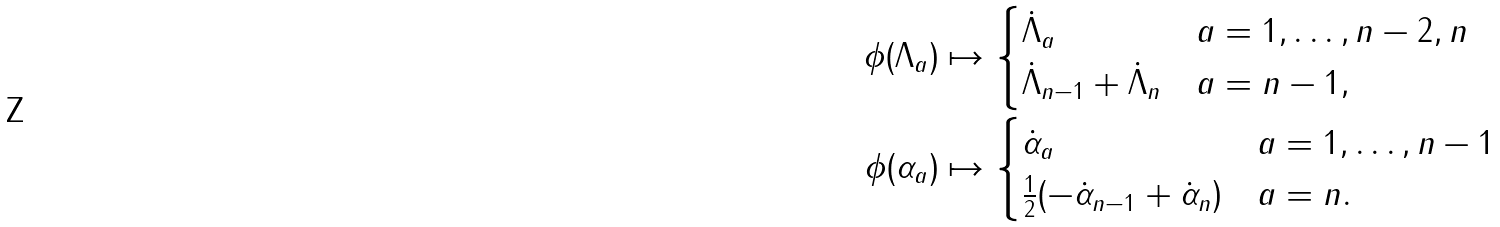<formula> <loc_0><loc_0><loc_500><loc_500>\phi ( \Lambda _ { a } ) & \mapsto \begin{cases} \dot { \Lambda } _ { a } & a = 1 , \dots , n - 2 , n \\ \dot { \Lambda } _ { n - 1 } + \dot { \Lambda } _ { n } & a = n - 1 , \\ \end{cases} \\ \phi ( \alpha _ { a } ) & \mapsto \begin{cases} \dot { \alpha } _ { a } & a = 1 , \dots , n - 1 \\ \frac { 1 } { 2 } ( - \dot { \alpha } _ { n - 1 } + \dot { \alpha } _ { n } ) & a = n . \\ \end{cases}</formula> 